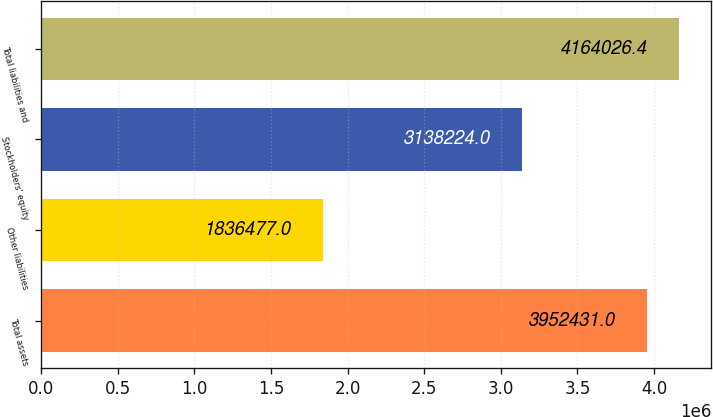Convert chart to OTSL. <chart><loc_0><loc_0><loc_500><loc_500><bar_chart><fcel>Total assets<fcel>Other liabilities<fcel>Stockholders' equity<fcel>Total liabilities and<nl><fcel>3.95243e+06<fcel>1.83648e+06<fcel>3.13822e+06<fcel>4.16403e+06<nl></chart> 